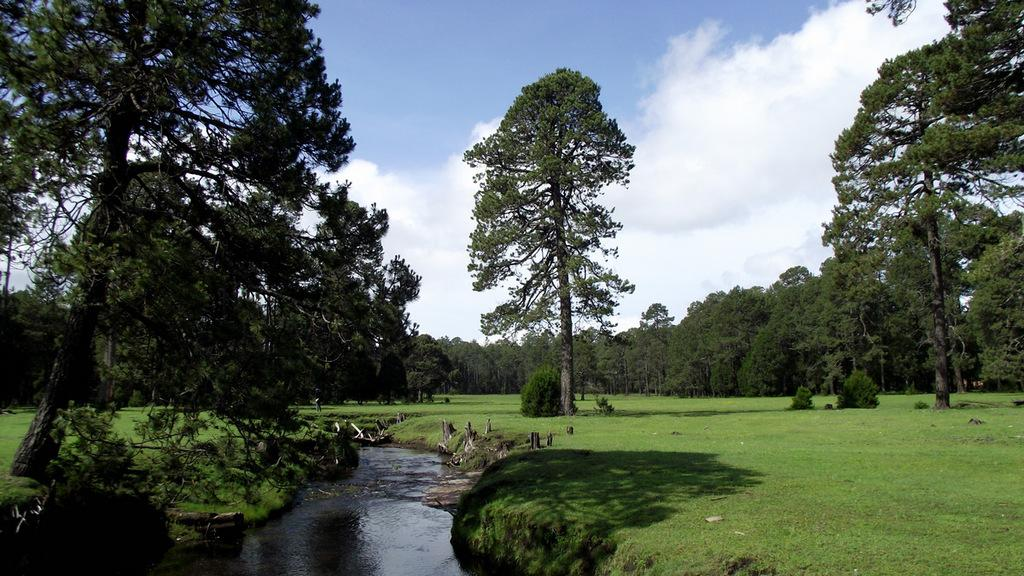What is happening in the image? There is a call in the image. What objects can be seen on the ground in the image? There are logs on the ground in the image. What type of terrain is visible in the image? The ground is visible in the image. What natural elements are present in the image? There are trees in the image. What can be seen in the background of the image? The sky is visible in the background of the image, and there are clouds in the sky. Can you describe the furniture used by the snail in the image? There is no snail or furniture present in the image. What type of thrill can be experienced by the person in the image? The image does not depict a person or any activity that would suggest a thrill. 